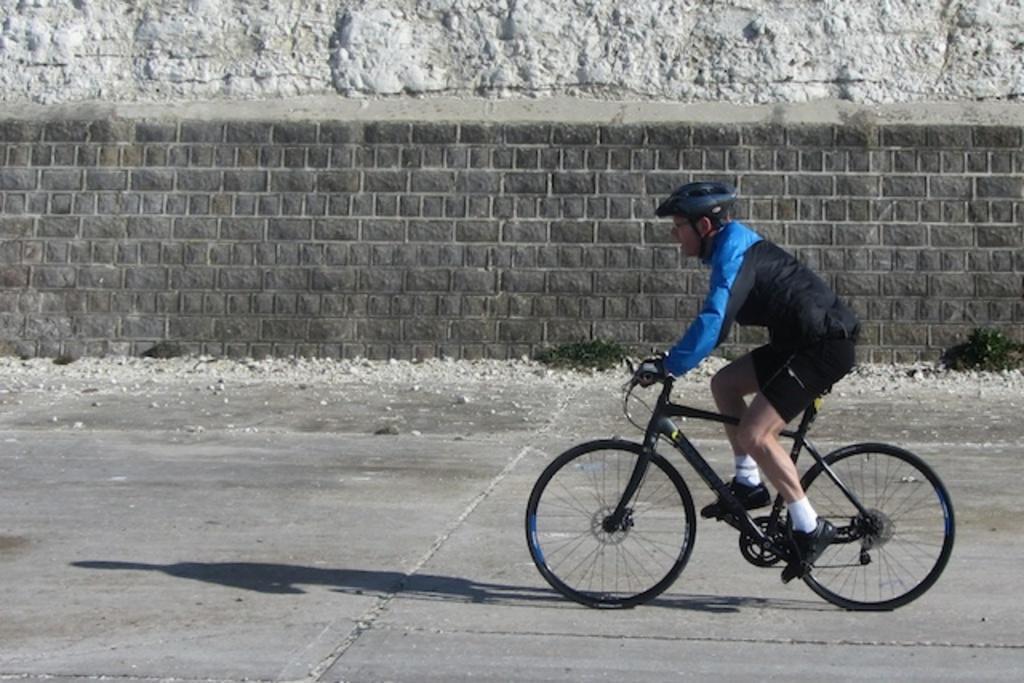Can you describe this image briefly? This image is clicked on the road. In the center there is a man riding bicycle on the road. Beside the road there is a wall. There is grass near to the wall. 